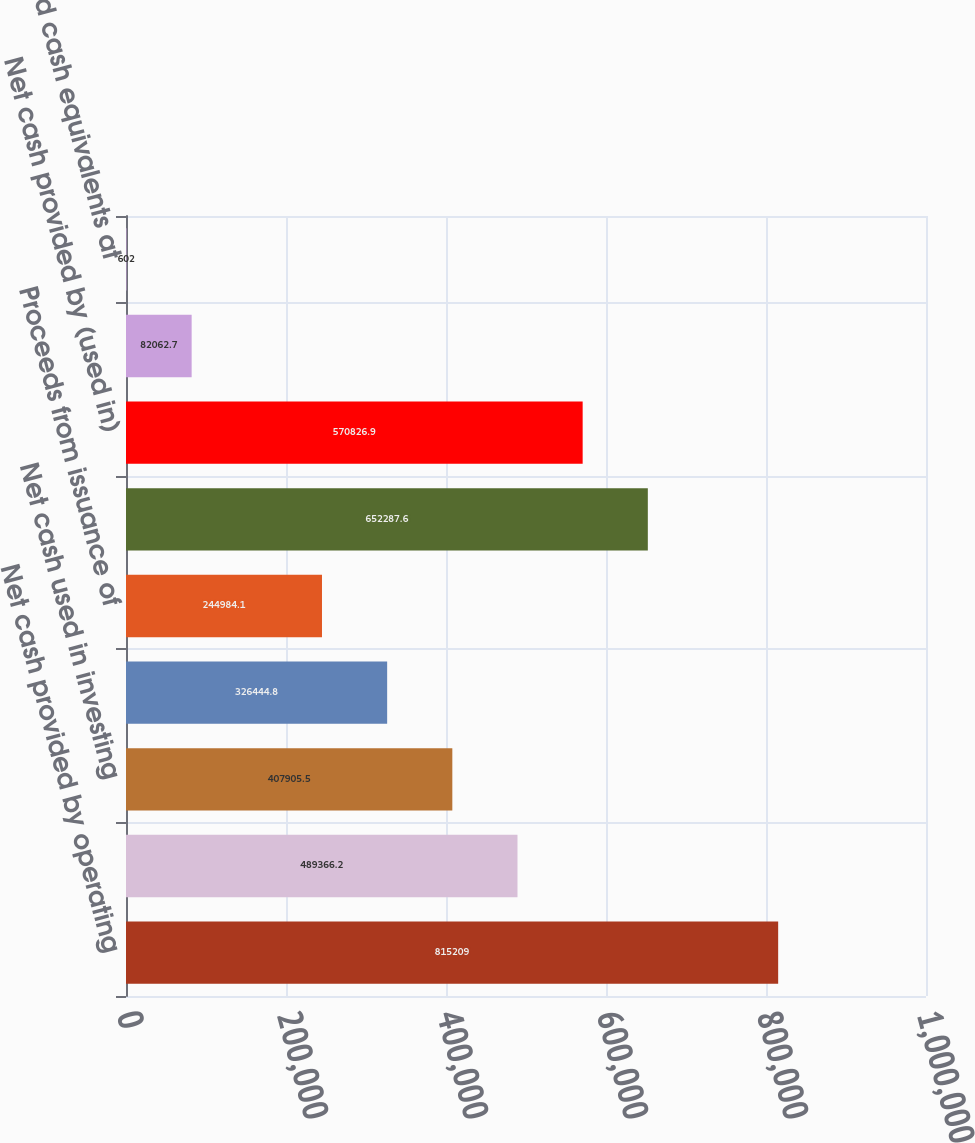Convert chart. <chart><loc_0><loc_0><loc_500><loc_500><bar_chart><fcel>Net cash provided by operating<fcel>Capital contributions to<fcel>Net cash used in investing<fcel>Proceeds from (repayment of)<fcel>Proceeds from issuance of<fcel>Dividends paid<fcel>Net cash provided by (used in)<fcel>Net change in cash and cash<fcel>Cash and cash equivalents at<nl><fcel>815209<fcel>489366<fcel>407906<fcel>326445<fcel>244984<fcel>652288<fcel>570827<fcel>82062.7<fcel>602<nl></chart> 